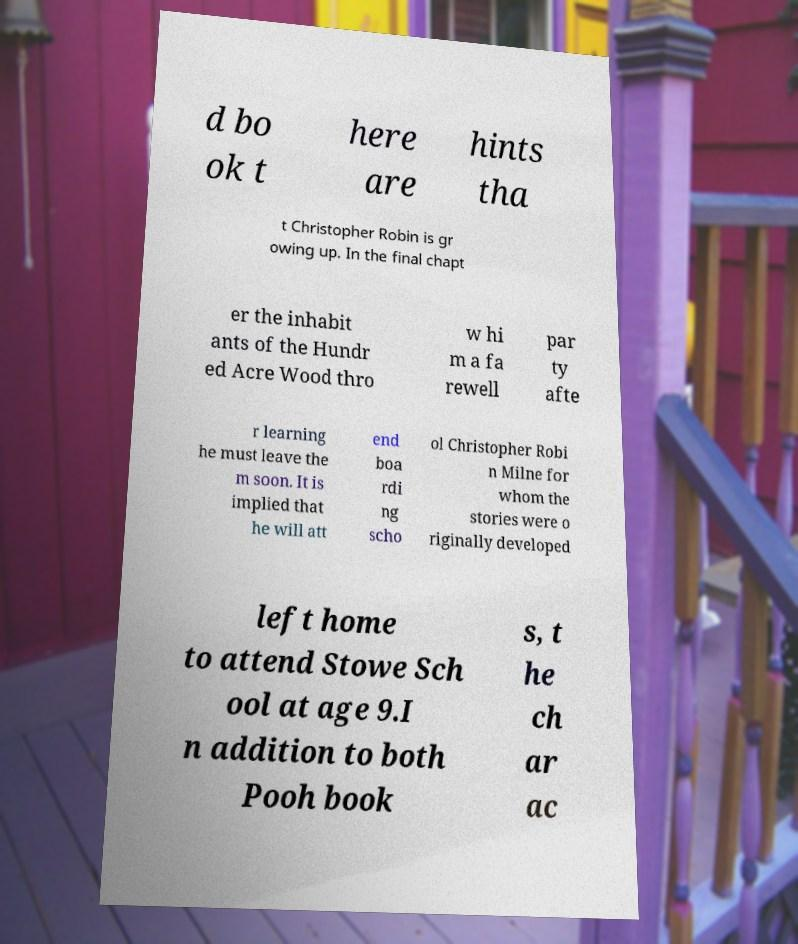Could you assist in decoding the text presented in this image and type it out clearly? d bo ok t here are hints tha t Christopher Robin is gr owing up. In the final chapt er the inhabit ants of the Hundr ed Acre Wood thro w hi m a fa rewell par ty afte r learning he must leave the m soon. It is implied that he will att end boa rdi ng scho ol Christopher Robi n Milne for whom the stories were o riginally developed left home to attend Stowe Sch ool at age 9.I n addition to both Pooh book s, t he ch ar ac 